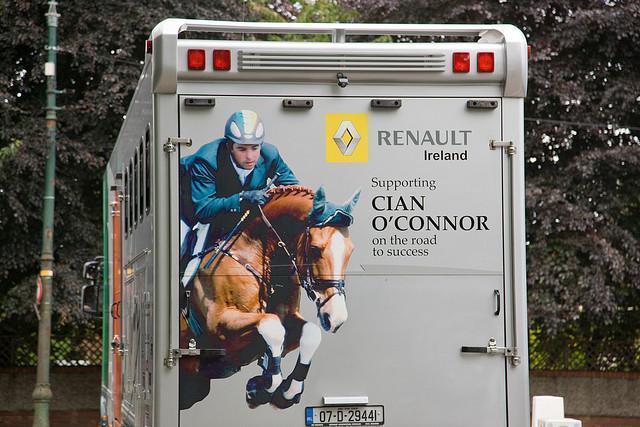Does the image validate the caption "The horse is part of the truck."?
Answer yes or no. Yes. 